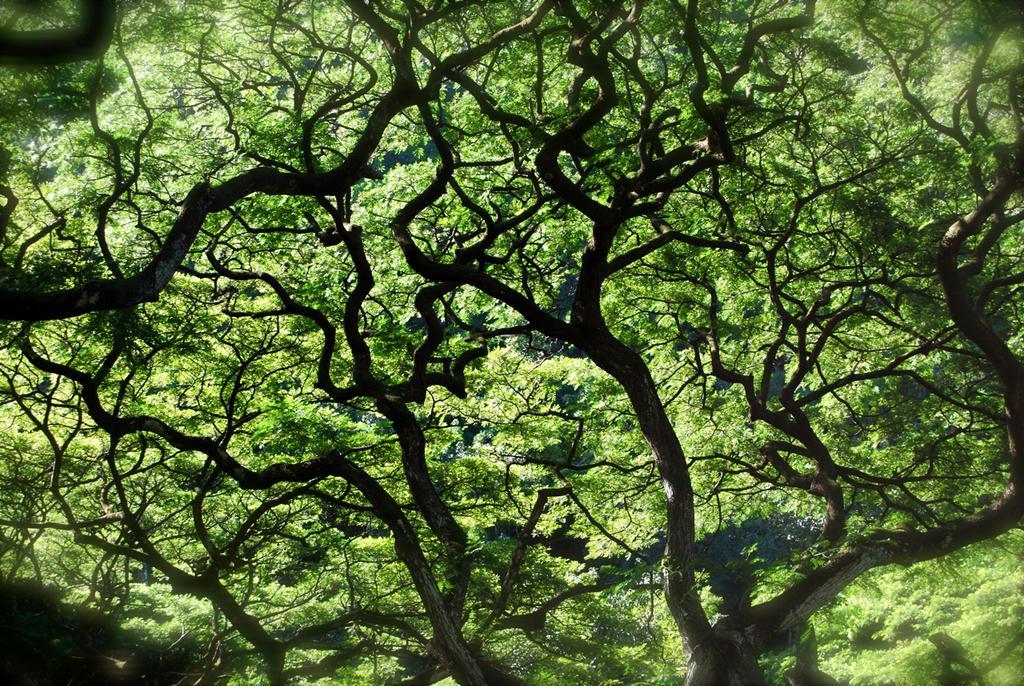Can you describe this image briefly? In this image I can see trees in green color and background the sky is in white color. 